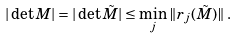Convert formula to latex. <formula><loc_0><loc_0><loc_500><loc_500>| \det M | = | \det \tilde { M } | \leq \min _ { j } \| r _ { j } ( \tilde { M } ) \| \, .</formula> 